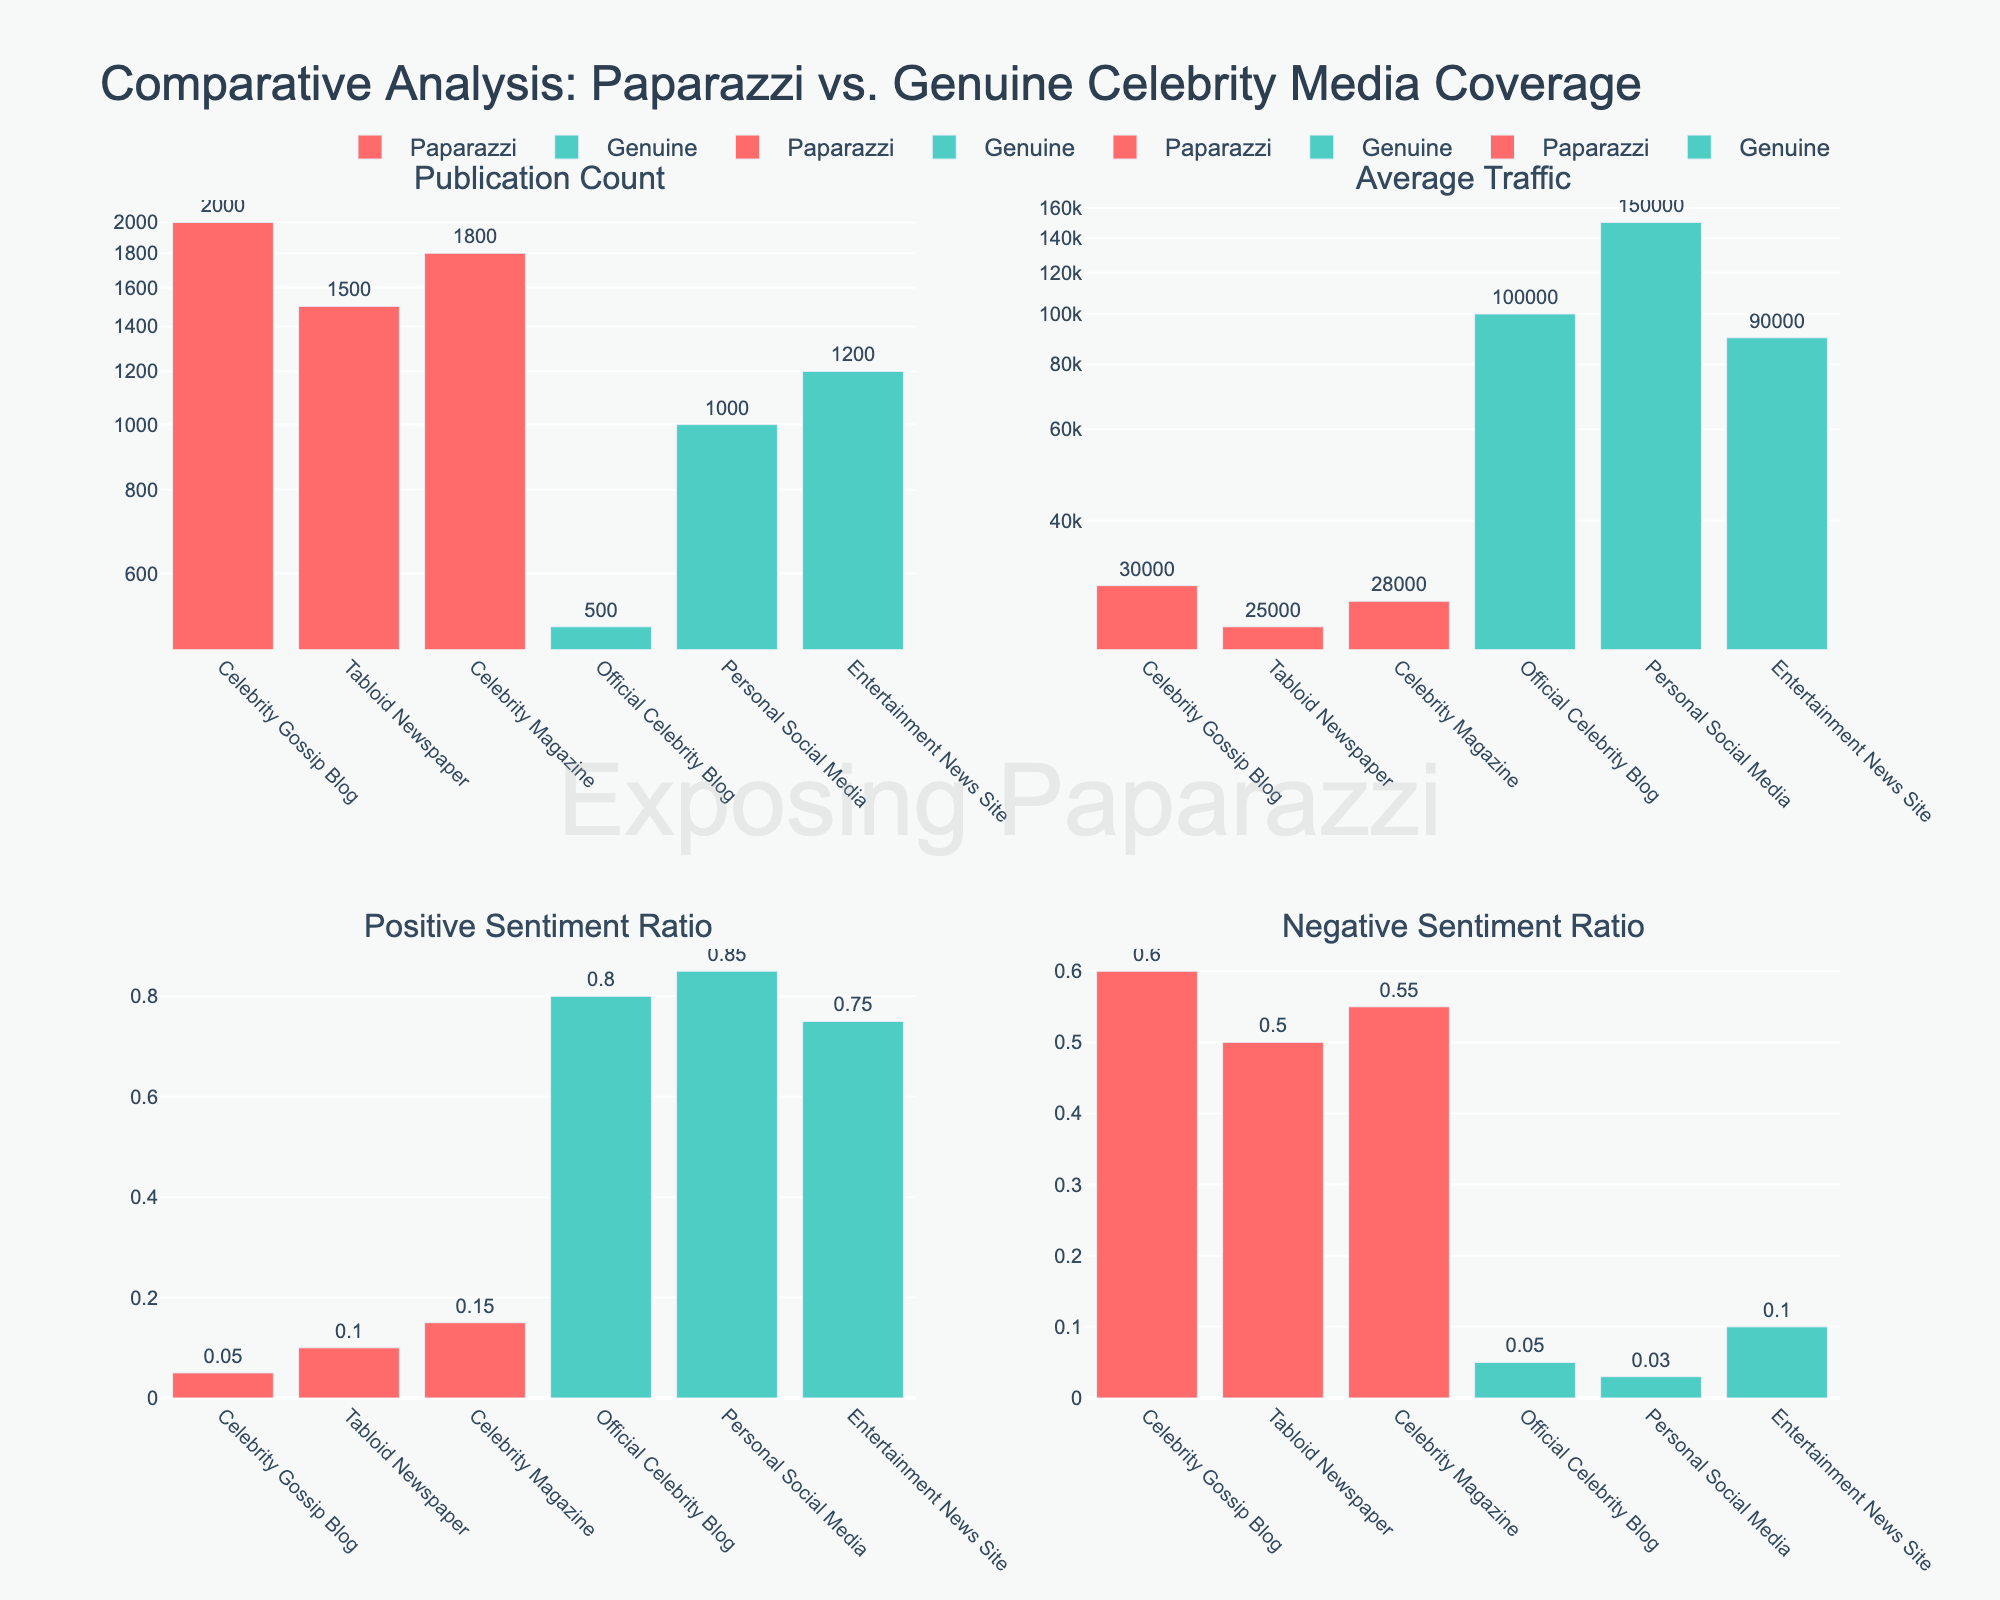What is the main title of the figure? The main title is usually found at the top of the figure. It summarizes the overall theme or subject of the figure. In this case, the main title reads "Comparative Analysis: Paparazzi vs. Genuine Celebrity Media Coverage"
Answer: Comparative Analysis: Paparazzi vs. Genuine Celebrity Media Coverage What axis scale is used for the "Publication Count" and "Average Traffic" subplots? The y-axis for these two subplots is represented in a log scale, which is commonly used to handle large ranges of values more effectively. The log scale is evident because the y-axis labels show exponential values.
Answer: Log scale Which data category has the higher average traffic in the "Average Traffic" subplot? Observe the bars in the "Average Traffic" subplot. The Genuine category, represented in teal color, shows higher average traffic figures for its data sources compared to the Paparazzi category.
Answer: Genuine How many publications are contributed by the Paparazzi category in total, based on the "Publication Count" subplot? Sum up the publication counts for all sources under the Paparazzi category: 2000 (Celebrity Gossip Blog) + 1500 (Tabloid Newspaper) + 1800 (Celebrity Magazine) = 5300.
Answer: 5300 Which source from the Paparazzi category has the highest positive sentiment ratio? Examine the "Positive Sentiment Ratio" subplot and look for the highest bar among the Paparazzi sources (red color). The highest positive sentiment ratio is from the Celebrity Magazine.
Answer: Celebrity Magazine Compare the negative sentiment ratios of Paparazzi (Celebrity Gossip Blog) and Genuine (Entertainment News Site). Which one is higher and by how much? Check the "Negative Sentiment Ratio" subplot. The values are 0.60 for Celebrity Gossip Blog and 0.10 for Entertainment News Site. The difference is 0.60 - 0.10 = 0.50.
Answer: Celebrity Gossip Blog is higher by 0.50 In which subplot and category does the "Official Celebrity Blog" appear, and what visualization element indicates it? The "Official Celebrity Blog" appears in all subplots under the Genuine category, represented by teal bars. This can be identified by examining the x-axis labels and corresponding colors of the bars.
Answer: All subplots, Genuine, teal bars What is the average positive sentiment ratio for all sources under the Genuine category? Sum the positive sentiment ratios for the Genuine sources: 0.80 (Official Celebrity Blog) + 0.85 (Personal Social Media) + 0.75 (Entertainment News Site). The sum is 2.40. The average is 2.40 / 3 = 0.80.
Answer: 0.80 Can you identify any source from the Genuine category that has a higher negative sentiment ratio than at least one source from the Paparazzi category? Compare all values in the "Negative Sentiment Ratio" subplot. No Genuine source (values: 0.05, 0.03, 0.10) has a higher negative sentiment ratio than any Paparazzi source (values: 0.60, 0.50, 0.55).
Answer: No 